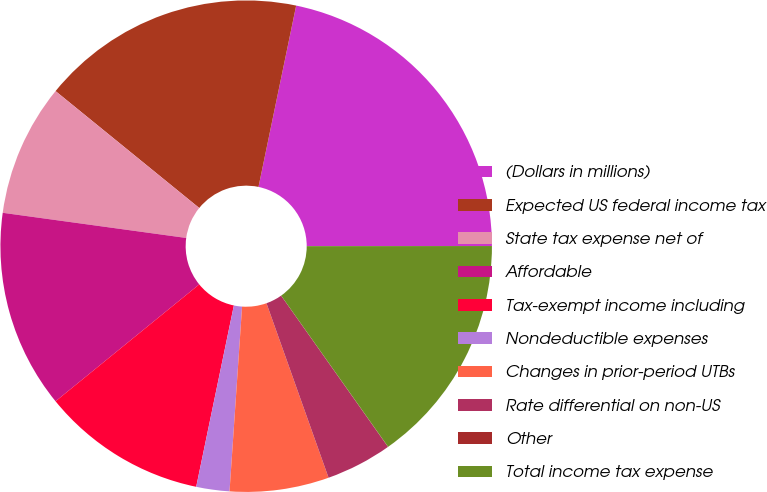Convert chart. <chart><loc_0><loc_0><loc_500><loc_500><pie_chart><fcel>(Dollars in millions)<fcel>Expected US federal income tax<fcel>State tax expense net of<fcel>Affordable<fcel>Tax-exempt income including<fcel>Nondeductible expenses<fcel>Changes in prior-period UTBs<fcel>Rate differential on non-US<fcel>Other<fcel>Total income tax expense<nl><fcel>21.73%<fcel>17.39%<fcel>8.7%<fcel>13.04%<fcel>10.87%<fcel>2.18%<fcel>6.52%<fcel>4.35%<fcel>0.01%<fcel>15.21%<nl></chart> 